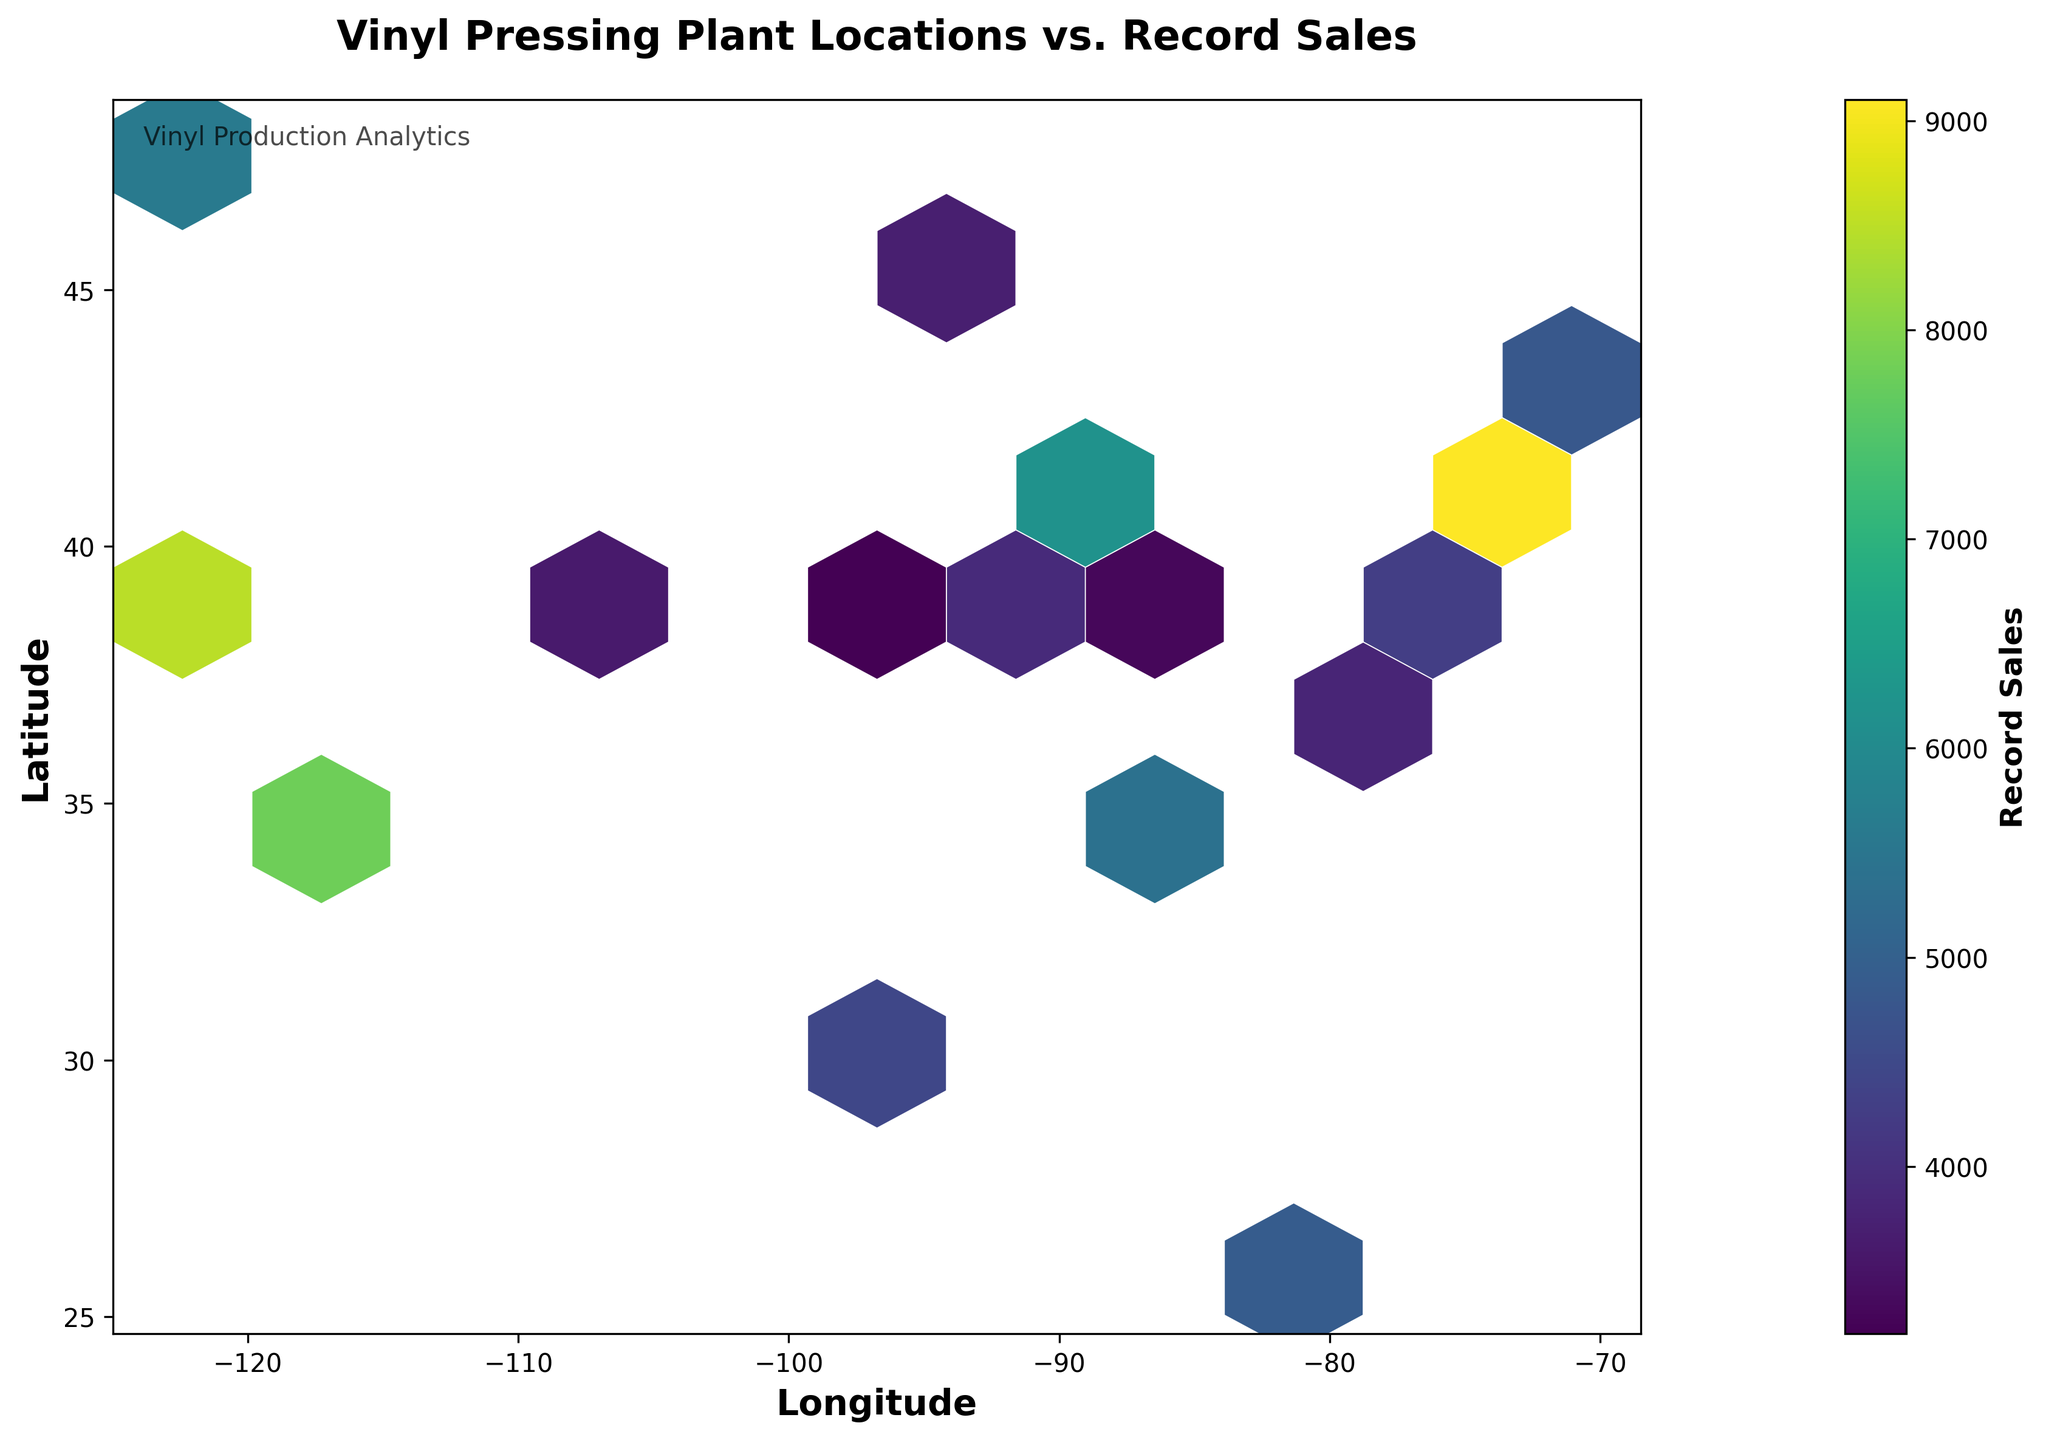What is the title of the figure? The title is usually located at the top of the figure and provides a summary of what the figure represents.
Answer: Vinyl Pressing Plant Locations vs. Record Sales What do the colors in the hexagons represent? The figure uses a color scale typically represented by a color bar on the side. The colors usually represent the magnitude of the variable 'value', which in this case, is Record Sales.
Answer: Record Sales Which longitude and latitude ranges are covered in the plot? The x-axis and y-axis labels denote the ranges for longitude and latitude, respectively. By examining the axes, one can determine the geographical coverage of the plot.
Answer: Longitude: -125 to -70, Latitude: 25 to 50 Which location has the highest record sales based on the hexbin plot? The highest value can be determined by finding the hex bin with the most saturated color (according to the color scale provided).
Answer: -73.9352, 40.7306 How many data points are concentrated around the coordinates (-90, 40)? To answer this question, you would look at the cluster density around the specified coordinates by interpreting the color saturation of the hex bins in that area.
Answer: High concentration around 3-5 points Which region shows a higher density of pressing plants: the West Coast or the East Coast? By comparing the color intensity and the number of hex bins in both coastal areas, the density of pressing plants can be inferred.
Answer: East Coast What is the average record sales in the region surrounding coordinates (-95, 30)? To find the average, identify the hex bins near (-95, 30) and find their corresponding values in the color scale. Add these values and divide by the number of bins.
Answer: Approximately 4200 Is there a noticeable correlation between vinyl pressing plant locations and record sales in surrounding regions? This can be determined by observing the clustering of colored hex bins. High densities or clusters of certain colors indicate a correlation.
Answer: Yes Which city among the data points has the lowest record sales? By examining the color saturation of the hex bins and referring to the color scale, it is possible to find the hex bin with the lowest value.
Answer: (-84.5120, 39.1031) What does a more saturated color in the hexbin plot indicate? The color bar helps interpret the intensity of the color, where more saturated colors usually indicate higher values.
Answer: Higher Record Sales 